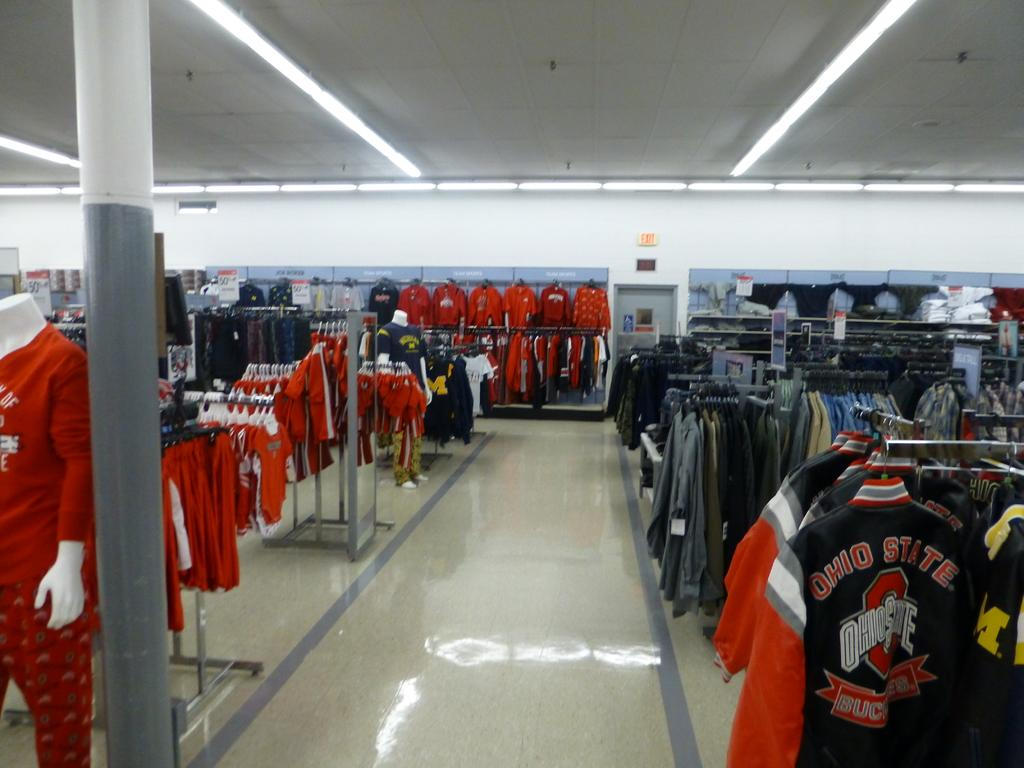Provide a one-sentence caption for the provided image. A clothing store featuring a lot of Ohio State clothing. 